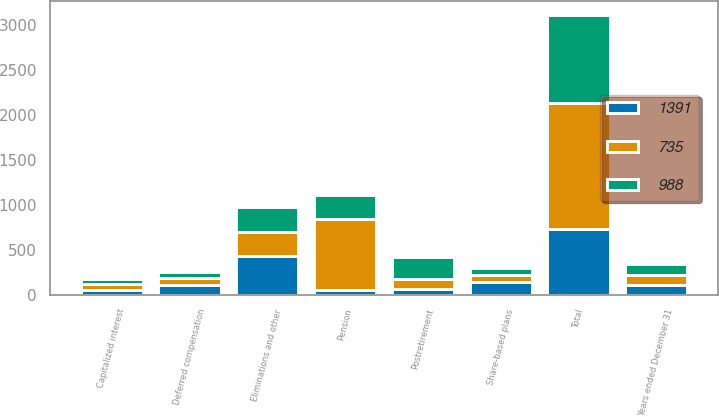Convert chart to OTSL. <chart><loc_0><loc_0><loc_500><loc_500><stacked_bar_chart><ecel><fcel>Years ended December 31<fcel>Share-based plans<fcel>Deferred compensation<fcel>Pension<fcel>Postretirement<fcel>Capitalized interest<fcel>Eliminations and other<fcel>Total<nl><fcel>735<fcel>112<fcel>81<fcel>75<fcel>787<fcel>112<fcel>70<fcel>266<fcel>1391<nl><fcel>988<fcel>112<fcel>83<fcel>61<fcel>269<fcel>248<fcel>51<fcel>276<fcel>988<nl><fcel>1391<fcel>112<fcel>136<fcel>112<fcel>54<fcel>59<fcel>54<fcel>428<fcel>735<nl></chart> 